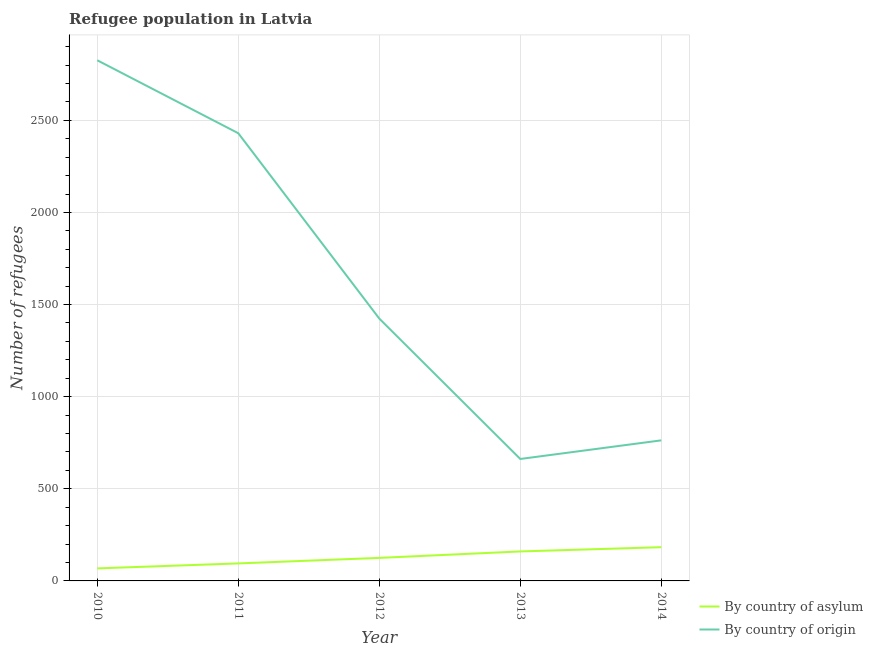How many different coloured lines are there?
Your response must be concise. 2. What is the number of refugees by country of origin in 2012?
Provide a succinct answer. 1424. Across all years, what is the maximum number of refugees by country of origin?
Your answer should be very brief. 2826. Across all years, what is the minimum number of refugees by country of origin?
Your answer should be compact. 662. In which year was the number of refugees by country of asylum maximum?
Your response must be concise. 2014. In which year was the number of refugees by country of asylum minimum?
Offer a terse response. 2010. What is the total number of refugees by country of asylum in the graph?
Ensure brevity in your answer.  631. What is the difference between the number of refugees by country of origin in 2012 and that in 2014?
Make the answer very short. 661. What is the difference between the number of refugees by country of origin in 2011 and the number of refugees by country of asylum in 2014?
Make the answer very short. 2247. What is the average number of refugees by country of origin per year?
Keep it short and to the point. 1621. In the year 2010, what is the difference between the number of refugees by country of origin and number of refugees by country of asylum?
Provide a succinct answer. 2758. What is the ratio of the number of refugees by country of origin in 2012 to that in 2013?
Provide a short and direct response. 2.15. Is the number of refugees by country of asylum in 2010 less than that in 2014?
Your answer should be very brief. Yes. What is the difference between the highest and the lowest number of refugees by country of asylum?
Give a very brief answer. 115. Is the sum of the number of refugees by country of asylum in 2010 and 2011 greater than the maximum number of refugees by country of origin across all years?
Give a very brief answer. No. Does the number of refugees by country of origin monotonically increase over the years?
Keep it short and to the point. No. Is the number of refugees by country of origin strictly greater than the number of refugees by country of asylum over the years?
Ensure brevity in your answer.  Yes. Does the graph contain any zero values?
Give a very brief answer. No. Does the graph contain grids?
Offer a terse response. Yes. What is the title of the graph?
Your answer should be compact. Refugee population in Latvia. Does "Female entrants" appear as one of the legend labels in the graph?
Ensure brevity in your answer.  No. What is the label or title of the Y-axis?
Your answer should be very brief. Number of refugees. What is the Number of refugees of By country of origin in 2010?
Your answer should be compact. 2826. What is the Number of refugees in By country of origin in 2011?
Your answer should be compact. 2430. What is the Number of refugees of By country of asylum in 2012?
Provide a short and direct response. 125. What is the Number of refugees in By country of origin in 2012?
Provide a succinct answer. 1424. What is the Number of refugees in By country of asylum in 2013?
Your response must be concise. 160. What is the Number of refugees in By country of origin in 2013?
Provide a short and direct response. 662. What is the Number of refugees of By country of asylum in 2014?
Provide a succinct answer. 183. What is the Number of refugees of By country of origin in 2014?
Your response must be concise. 763. Across all years, what is the maximum Number of refugees of By country of asylum?
Give a very brief answer. 183. Across all years, what is the maximum Number of refugees of By country of origin?
Offer a very short reply. 2826. Across all years, what is the minimum Number of refugees in By country of asylum?
Keep it short and to the point. 68. Across all years, what is the minimum Number of refugees of By country of origin?
Make the answer very short. 662. What is the total Number of refugees in By country of asylum in the graph?
Provide a succinct answer. 631. What is the total Number of refugees of By country of origin in the graph?
Offer a very short reply. 8105. What is the difference between the Number of refugees of By country of asylum in 2010 and that in 2011?
Offer a terse response. -27. What is the difference between the Number of refugees of By country of origin in 2010 and that in 2011?
Your answer should be very brief. 396. What is the difference between the Number of refugees in By country of asylum in 2010 and that in 2012?
Ensure brevity in your answer.  -57. What is the difference between the Number of refugees of By country of origin in 2010 and that in 2012?
Provide a succinct answer. 1402. What is the difference between the Number of refugees of By country of asylum in 2010 and that in 2013?
Your answer should be very brief. -92. What is the difference between the Number of refugees of By country of origin in 2010 and that in 2013?
Give a very brief answer. 2164. What is the difference between the Number of refugees in By country of asylum in 2010 and that in 2014?
Make the answer very short. -115. What is the difference between the Number of refugees in By country of origin in 2010 and that in 2014?
Offer a very short reply. 2063. What is the difference between the Number of refugees in By country of origin in 2011 and that in 2012?
Your answer should be very brief. 1006. What is the difference between the Number of refugees of By country of asylum in 2011 and that in 2013?
Your answer should be very brief. -65. What is the difference between the Number of refugees of By country of origin in 2011 and that in 2013?
Give a very brief answer. 1768. What is the difference between the Number of refugees of By country of asylum in 2011 and that in 2014?
Provide a short and direct response. -88. What is the difference between the Number of refugees of By country of origin in 2011 and that in 2014?
Keep it short and to the point. 1667. What is the difference between the Number of refugees of By country of asylum in 2012 and that in 2013?
Offer a terse response. -35. What is the difference between the Number of refugees of By country of origin in 2012 and that in 2013?
Ensure brevity in your answer.  762. What is the difference between the Number of refugees of By country of asylum in 2012 and that in 2014?
Ensure brevity in your answer.  -58. What is the difference between the Number of refugees in By country of origin in 2012 and that in 2014?
Give a very brief answer. 661. What is the difference between the Number of refugees of By country of asylum in 2013 and that in 2014?
Ensure brevity in your answer.  -23. What is the difference between the Number of refugees of By country of origin in 2013 and that in 2014?
Give a very brief answer. -101. What is the difference between the Number of refugees of By country of asylum in 2010 and the Number of refugees of By country of origin in 2011?
Your answer should be compact. -2362. What is the difference between the Number of refugees in By country of asylum in 2010 and the Number of refugees in By country of origin in 2012?
Make the answer very short. -1356. What is the difference between the Number of refugees of By country of asylum in 2010 and the Number of refugees of By country of origin in 2013?
Provide a succinct answer. -594. What is the difference between the Number of refugees of By country of asylum in 2010 and the Number of refugees of By country of origin in 2014?
Your answer should be compact. -695. What is the difference between the Number of refugees in By country of asylum in 2011 and the Number of refugees in By country of origin in 2012?
Your answer should be very brief. -1329. What is the difference between the Number of refugees of By country of asylum in 2011 and the Number of refugees of By country of origin in 2013?
Give a very brief answer. -567. What is the difference between the Number of refugees of By country of asylum in 2011 and the Number of refugees of By country of origin in 2014?
Offer a very short reply. -668. What is the difference between the Number of refugees in By country of asylum in 2012 and the Number of refugees in By country of origin in 2013?
Make the answer very short. -537. What is the difference between the Number of refugees of By country of asylum in 2012 and the Number of refugees of By country of origin in 2014?
Provide a succinct answer. -638. What is the difference between the Number of refugees of By country of asylum in 2013 and the Number of refugees of By country of origin in 2014?
Offer a very short reply. -603. What is the average Number of refugees of By country of asylum per year?
Provide a short and direct response. 126.2. What is the average Number of refugees in By country of origin per year?
Offer a terse response. 1621. In the year 2010, what is the difference between the Number of refugees of By country of asylum and Number of refugees of By country of origin?
Ensure brevity in your answer.  -2758. In the year 2011, what is the difference between the Number of refugees in By country of asylum and Number of refugees in By country of origin?
Offer a very short reply. -2335. In the year 2012, what is the difference between the Number of refugees in By country of asylum and Number of refugees in By country of origin?
Your answer should be very brief. -1299. In the year 2013, what is the difference between the Number of refugees in By country of asylum and Number of refugees in By country of origin?
Your response must be concise. -502. In the year 2014, what is the difference between the Number of refugees in By country of asylum and Number of refugees in By country of origin?
Offer a very short reply. -580. What is the ratio of the Number of refugees of By country of asylum in 2010 to that in 2011?
Keep it short and to the point. 0.72. What is the ratio of the Number of refugees of By country of origin in 2010 to that in 2011?
Offer a very short reply. 1.16. What is the ratio of the Number of refugees in By country of asylum in 2010 to that in 2012?
Your answer should be very brief. 0.54. What is the ratio of the Number of refugees of By country of origin in 2010 to that in 2012?
Your answer should be very brief. 1.98. What is the ratio of the Number of refugees in By country of asylum in 2010 to that in 2013?
Provide a short and direct response. 0.42. What is the ratio of the Number of refugees in By country of origin in 2010 to that in 2013?
Offer a very short reply. 4.27. What is the ratio of the Number of refugees in By country of asylum in 2010 to that in 2014?
Give a very brief answer. 0.37. What is the ratio of the Number of refugees in By country of origin in 2010 to that in 2014?
Your answer should be compact. 3.7. What is the ratio of the Number of refugees in By country of asylum in 2011 to that in 2012?
Make the answer very short. 0.76. What is the ratio of the Number of refugees in By country of origin in 2011 to that in 2012?
Keep it short and to the point. 1.71. What is the ratio of the Number of refugees of By country of asylum in 2011 to that in 2013?
Give a very brief answer. 0.59. What is the ratio of the Number of refugees in By country of origin in 2011 to that in 2013?
Your answer should be very brief. 3.67. What is the ratio of the Number of refugees in By country of asylum in 2011 to that in 2014?
Provide a short and direct response. 0.52. What is the ratio of the Number of refugees in By country of origin in 2011 to that in 2014?
Your answer should be compact. 3.18. What is the ratio of the Number of refugees in By country of asylum in 2012 to that in 2013?
Ensure brevity in your answer.  0.78. What is the ratio of the Number of refugees of By country of origin in 2012 to that in 2013?
Make the answer very short. 2.15. What is the ratio of the Number of refugees of By country of asylum in 2012 to that in 2014?
Ensure brevity in your answer.  0.68. What is the ratio of the Number of refugees in By country of origin in 2012 to that in 2014?
Offer a very short reply. 1.87. What is the ratio of the Number of refugees of By country of asylum in 2013 to that in 2014?
Offer a very short reply. 0.87. What is the ratio of the Number of refugees of By country of origin in 2013 to that in 2014?
Your answer should be very brief. 0.87. What is the difference between the highest and the second highest Number of refugees of By country of asylum?
Ensure brevity in your answer.  23. What is the difference between the highest and the second highest Number of refugees in By country of origin?
Your answer should be compact. 396. What is the difference between the highest and the lowest Number of refugees in By country of asylum?
Provide a short and direct response. 115. What is the difference between the highest and the lowest Number of refugees of By country of origin?
Offer a very short reply. 2164. 